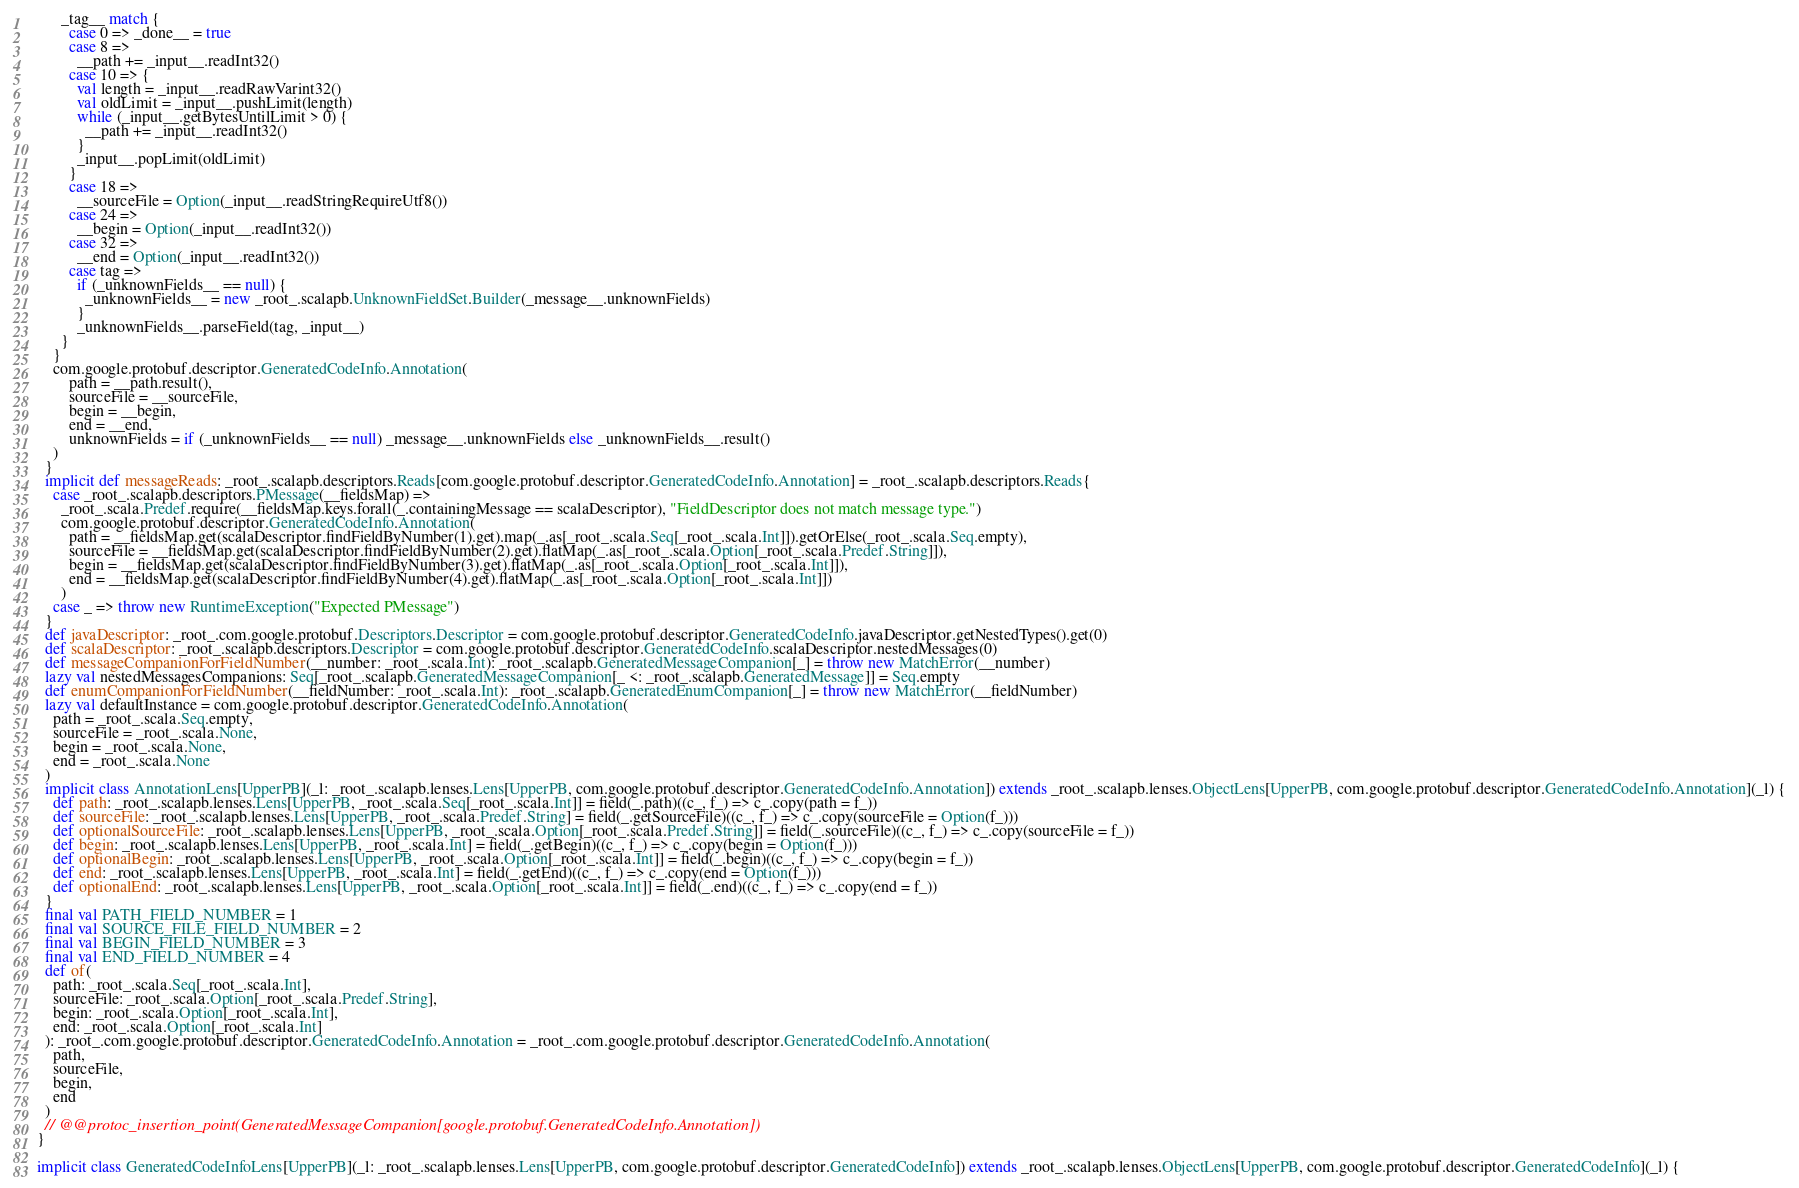<code> <loc_0><loc_0><loc_500><loc_500><_Scala_>        _tag__ match {
          case 0 => _done__ = true
          case 8 =>
            __path += _input__.readInt32()
          case 10 => {
            val length = _input__.readRawVarint32()
            val oldLimit = _input__.pushLimit(length)
            while (_input__.getBytesUntilLimit > 0) {
              __path += _input__.readInt32()
            }
            _input__.popLimit(oldLimit)
          }
          case 18 =>
            __sourceFile = Option(_input__.readStringRequireUtf8())
          case 24 =>
            __begin = Option(_input__.readInt32())
          case 32 =>
            __end = Option(_input__.readInt32())
          case tag =>
            if (_unknownFields__ == null) {
              _unknownFields__ = new _root_.scalapb.UnknownFieldSet.Builder(_message__.unknownFields)
            }
            _unknownFields__.parseField(tag, _input__)
        }
      }
      com.google.protobuf.descriptor.GeneratedCodeInfo.Annotation(
          path = __path.result(),
          sourceFile = __sourceFile,
          begin = __begin,
          end = __end,
          unknownFields = if (_unknownFields__ == null) _message__.unknownFields else _unknownFields__.result()
      )
    }
    implicit def messageReads: _root_.scalapb.descriptors.Reads[com.google.protobuf.descriptor.GeneratedCodeInfo.Annotation] = _root_.scalapb.descriptors.Reads{
      case _root_.scalapb.descriptors.PMessage(__fieldsMap) =>
        _root_.scala.Predef.require(__fieldsMap.keys.forall(_.containingMessage == scalaDescriptor), "FieldDescriptor does not match message type.")
        com.google.protobuf.descriptor.GeneratedCodeInfo.Annotation(
          path = __fieldsMap.get(scalaDescriptor.findFieldByNumber(1).get).map(_.as[_root_.scala.Seq[_root_.scala.Int]]).getOrElse(_root_.scala.Seq.empty),
          sourceFile = __fieldsMap.get(scalaDescriptor.findFieldByNumber(2).get).flatMap(_.as[_root_.scala.Option[_root_.scala.Predef.String]]),
          begin = __fieldsMap.get(scalaDescriptor.findFieldByNumber(3).get).flatMap(_.as[_root_.scala.Option[_root_.scala.Int]]),
          end = __fieldsMap.get(scalaDescriptor.findFieldByNumber(4).get).flatMap(_.as[_root_.scala.Option[_root_.scala.Int]])
        )
      case _ => throw new RuntimeException("Expected PMessage")
    }
    def javaDescriptor: _root_.com.google.protobuf.Descriptors.Descriptor = com.google.protobuf.descriptor.GeneratedCodeInfo.javaDescriptor.getNestedTypes().get(0)
    def scalaDescriptor: _root_.scalapb.descriptors.Descriptor = com.google.protobuf.descriptor.GeneratedCodeInfo.scalaDescriptor.nestedMessages(0)
    def messageCompanionForFieldNumber(__number: _root_.scala.Int): _root_.scalapb.GeneratedMessageCompanion[_] = throw new MatchError(__number)
    lazy val nestedMessagesCompanions: Seq[_root_.scalapb.GeneratedMessageCompanion[_ <: _root_.scalapb.GeneratedMessage]] = Seq.empty
    def enumCompanionForFieldNumber(__fieldNumber: _root_.scala.Int): _root_.scalapb.GeneratedEnumCompanion[_] = throw new MatchError(__fieldNumber)
    lazy val defaultInstance = com.google.protobuf.descriptor.GeneratedCodeInfo.Annotation(
      path = _root_.scala.Seq.empty,
      sourceFile = _root_.scala.None,
      begin = _root_.scala.None,
      end = _root_.scala.None
    )
    implicit class AnnotationLens[UpperPB](_l: _root_.scalapb.lenses.Lens[UpperPB, com.google.protobuf.descriptor.GeneratedCodeInfo.Annotation]) extends _root_.scalapb.lenses.ObjectLens[UpperPB, com.google.protobuf.descriptor.GeneratedCodeInfo.Annotation](_l) {
      def path: _root_.scalapb.lenses.Lens[UpperPB, _root_.scala.Seq[_root_.scala.Int]] = field(_.path)((c_, f_) => c_.copy(path = f_))
      def sourceFile: _root_.scalapb.lenses.Lens[UpperPB, _root_.scala.Predef.String] = field(_.getSourceFile)((c_, f_) => c_.copy(sourceFile = Option(f_)))
      def optionalSourceFile: _root_.scalapb.lenses.Lens[UpperPB, _root_.scala.Option[_root_.scala.Predef.String]] = field(_.sourceFile)((c_, f_) => c_.copy(sourceFile = f_))
      def begin: _root_.scalapb.lenses.Lens[UpperPB, _root_.scala.Int] = field(_.getBegin)((c_, f_) => c_.copy(begin = Option(f_)))
      def optionalBegin: _root_.scalapb.lenses.Lens[UpperPB, _root_.scala.Option[_root_.scala.Int]] = field(_.begin)((c_, f_) => c_.copy(begin = f_))
      def end: _root_.scalapb.lenses.Lens[UpperPB, _root_.scala.Int] = field(_.getEnd)((c_, f_) => c_.copy(end = Option(f_)))
      def optionalEnd: _root_.scalapb.lenses.Lens[UpperPB, _root_.scala.Option[_root_.scala.Int]] = field(_.end)((c_, f_) => c_.copy(end = f_))
    }
    final val PATH_FIELD_NUMBER = 1
    final val SOURCE_FILE_FIELD_NUMBER = 2
    final val BEGIN_FIELD_NUMBER = 3
    final val END_FIELD_NUMBER = 4
    def of(
      path: _root_.scala.Seq[_root_.scala.Int],
      sourceFile: _root_.scala.Option[_root_.scala.Predef.String],
      begin: _root_.scala.Option[_root_.scala.Int],
      end: _root_.scala.Option[_root_.scala.Int]
    ): _root_.com.google.protobuf.descriptor.GeneratedCodeInfo.Annotation = _root_.com.google.protobuf.descriptor.GeneratedCodeInfo.Annotation(
      path,
      sourceFile,
      begin,
      end
    )
    // @@protoc_insertion_point(GeneratedMessageCompanion[google.protobuf.GeneratedCodeInfo.Annotation])
  }
  
  implicit class GeneratedCodeInfoLens[UpperPB](_l: _root_.scalapb.lenses.Lens[UpperPB, com.google.protobuf.descriptor.GeneratedCodeInfo]) extends _root_.scalapb.lenses.ObjectLens[UpperPB, com.google.protobuf.descriptor.GeneratedCodeInfo](_l) {</code> 